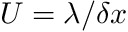Convert formula to latex. <formula><loc_0><loc_0><loc_500><loc_500>U = \lambda / \delta x</formula> 